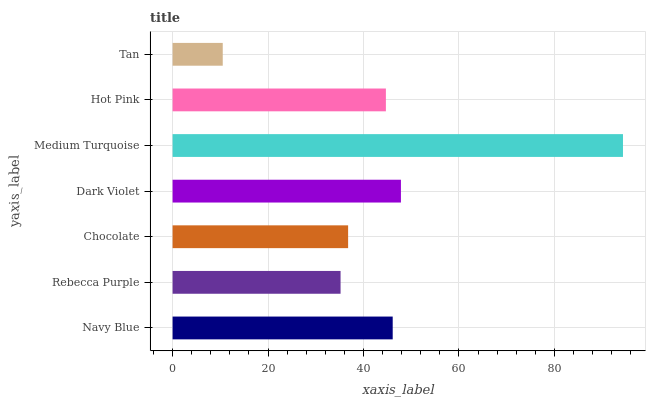Is Tan the minimum?
Answer yes or no. Yes. Is Medium Turquoise the maximum?
Answer yes or no. Yes. Is Rebecca Purple the minimum?
Answer yes or no. No. Is Rebecca Purple the maximum?
Answer yes or no. No. Is Navy Blue greater than Rebecca Purple?
Answer yes or no. Yes. Is Rebecca Purple less than Navy Blue?
Answer yes or no. Yes. Is Rebecca Purple greater than Navy Blue?
Answer yes or no. No. Is Navy Blue less than Rebecca Purple?
Answer yes or no. No. Is Hot Pink the high median?
Answer yes or no. Yes. Is Hot Pink the low median?
Answer yes or no. Yes. Is Dark Violet the high median?
Answer yes or no. No. Is Rebecca Purple the low median?
Answer yes or no. No. 